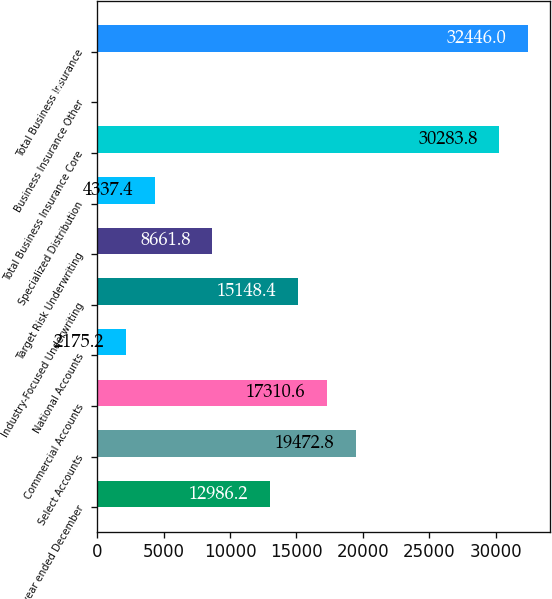Convert chart. <chart><loc_0><loc_0><loc_500><loc_500><bar_chart><fcel>(for the year ended December<fcel>Select Accounts<fcel>Commercial Accounts<fcel>National Accounts<fcel>Industry-Focused Underwriting<fcel>Target Risk Underwriting<fcel>Specialized Distribution<fcel>Total Business Insurance Core<fcel>Business Insurance Other<fcel>Total Business Insurance<nl><fcel>12986.2<fcel>19472.8<fcel>17310.6<fcel>2175.2<fcel>15148.4<fcel>8661.8<fcel>4337.4<fcel>30283.8<fcel>13<fcel>32446<nl></chart> 